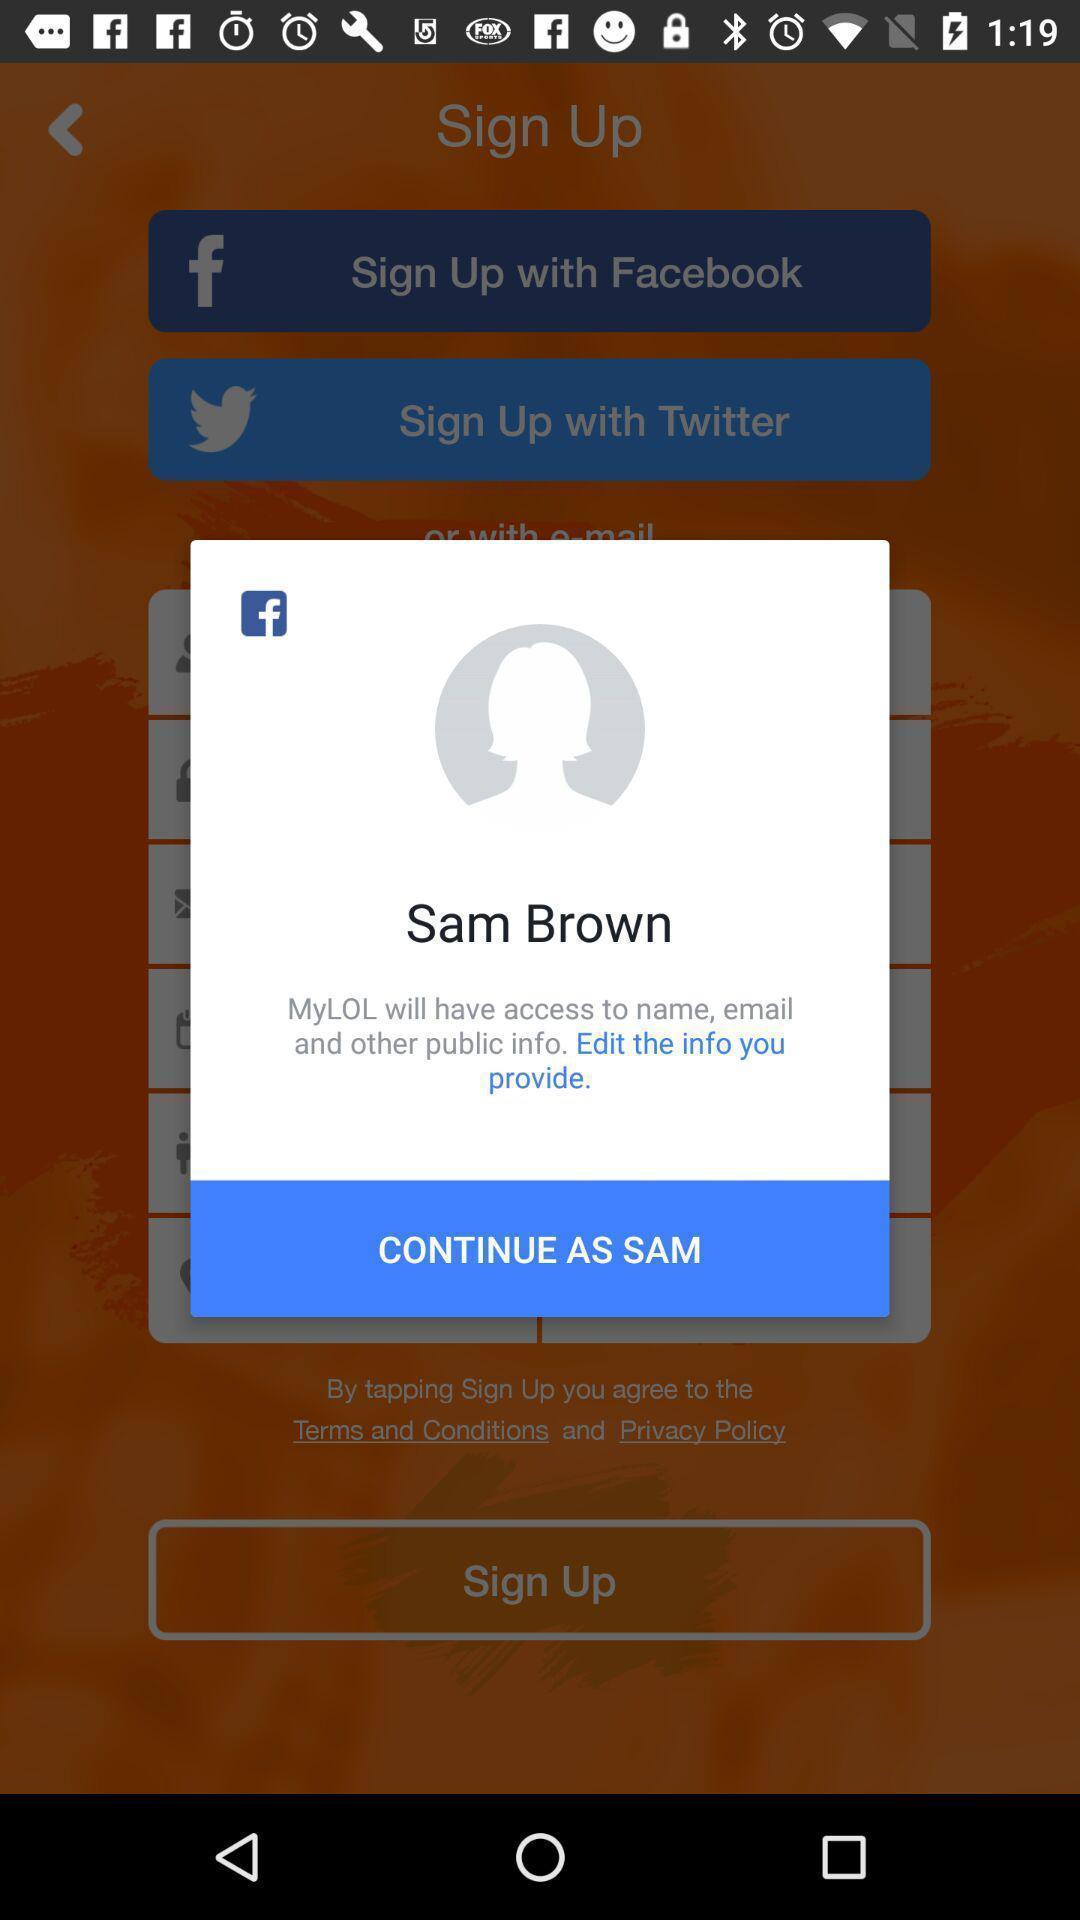What details can you identify in this image? Pop-up shows social icon with continue as sam. 